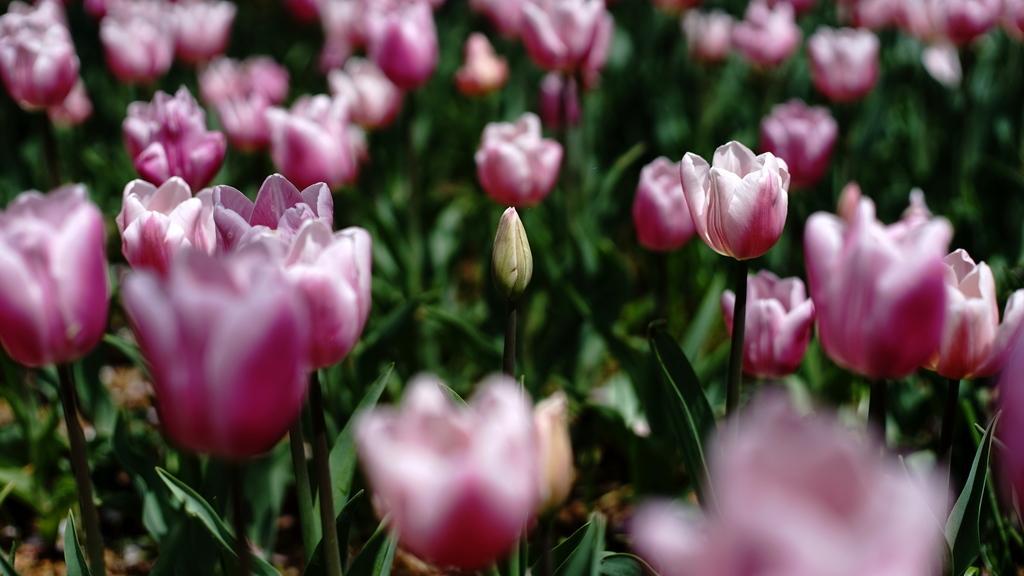Could you give a brief overview of what you see in this image? There are many tulip plants. 